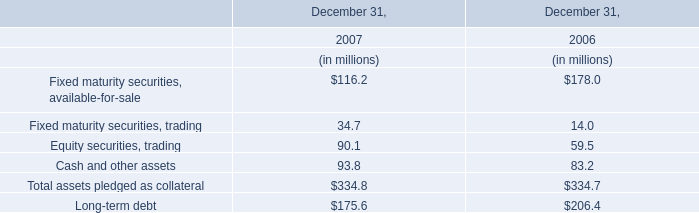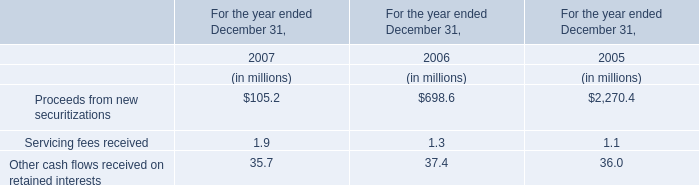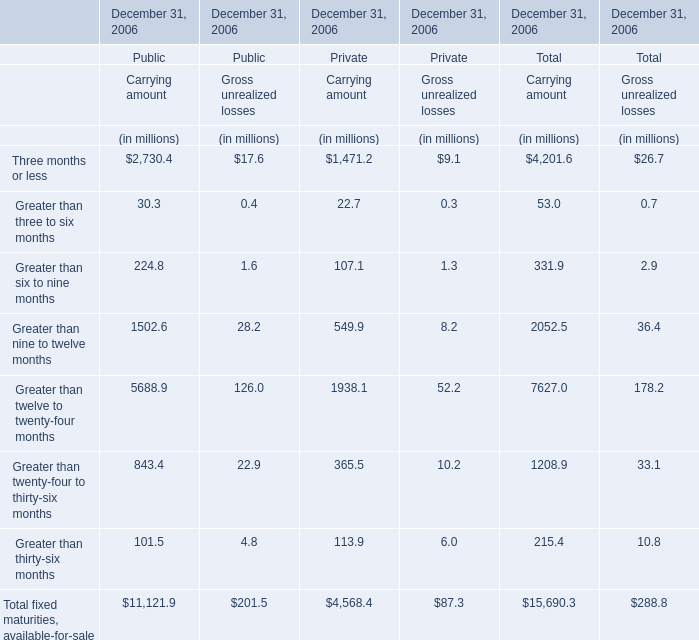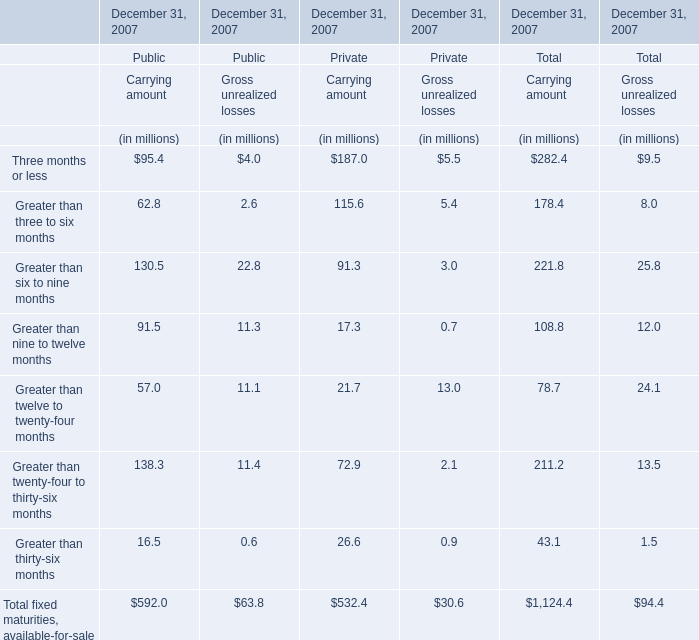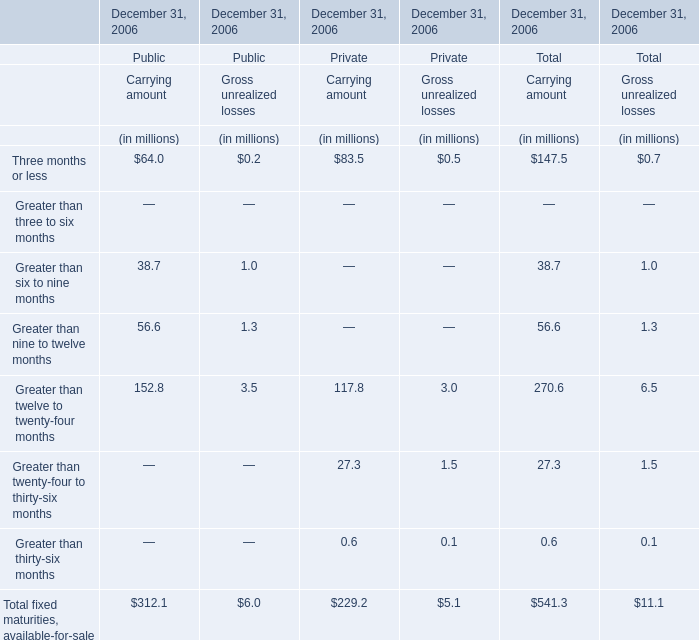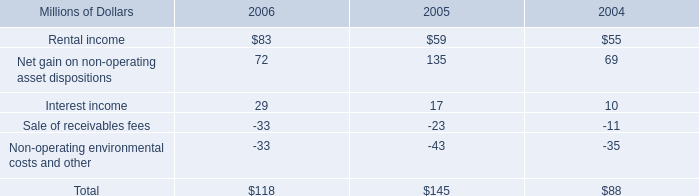What's the total value of all the Carrying amount for Private that are smaller than 50 million at December 31, 2006? (in million) 
Computations: (27.3 + 0.6)
Answer: 27.9. 